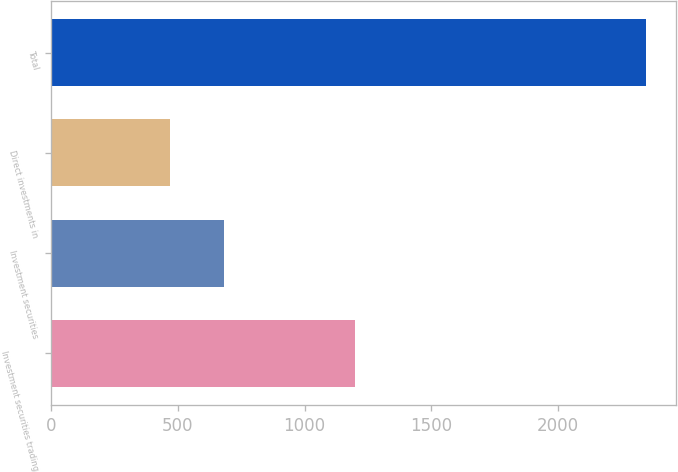Convert chart to OTSL. <chart><loc_0><loc_0><loc_500><loc_500><bar_chart><fcel>Investment securities trading<fcel>Investment securities<fcel>Direct investments in<fcel>Total<nl><fcel>1196.7<fcel>682.2<fcel>468<fcel>2346.9<nl></chart> 